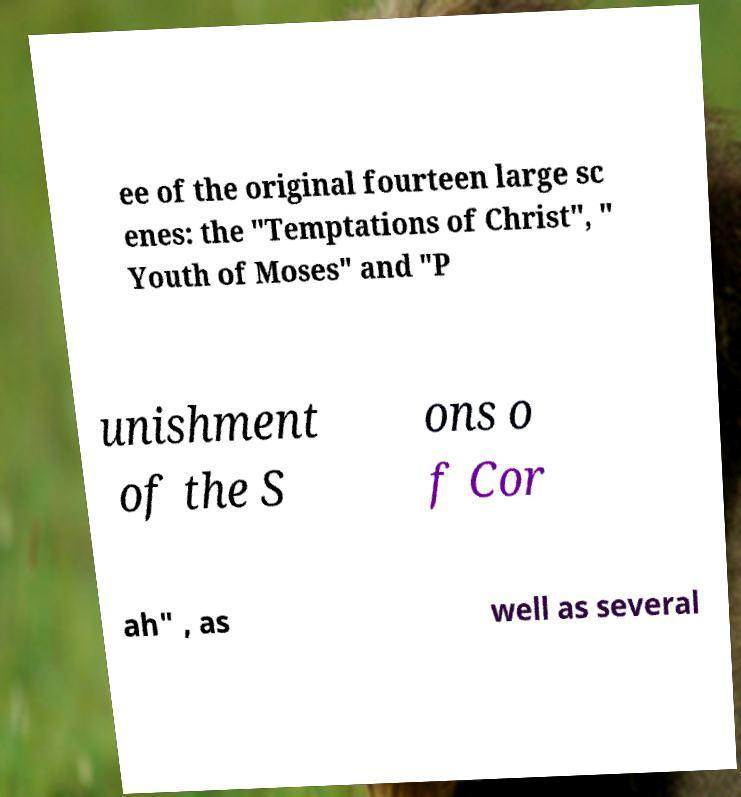For documentation purposes, I need the text within this image transcribed. Could you provide that? ee of the original fourteen large sc enes: the "Temptations of Christ", " Youth of Moses" and "P unishment of the S ons o f Cor ah" , as well as several 